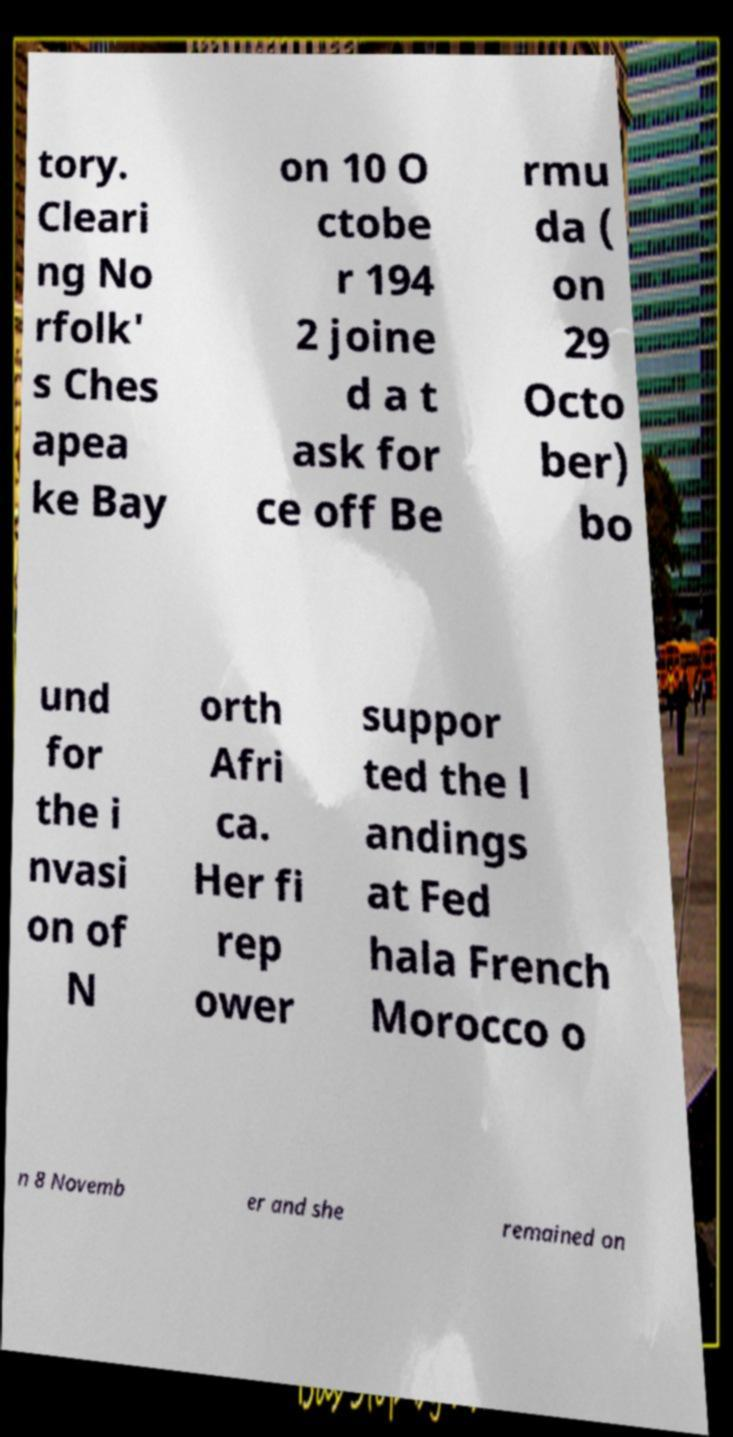For documentation purposes, I need the text within this image transcribed. Could you provide that? tory. Cleari ng No rfolk' s Ches apea ke Bay on 10 O ctobe r 194 2 joine d a t ask for ce off Be rmu da ( on 29 Octo ber) bo und for the i nvasi on of N orth Afri ca. Her fi rep ower suppor ted the l andings at Fed hala French Morocco o n 8 Novemb er and she remained on 